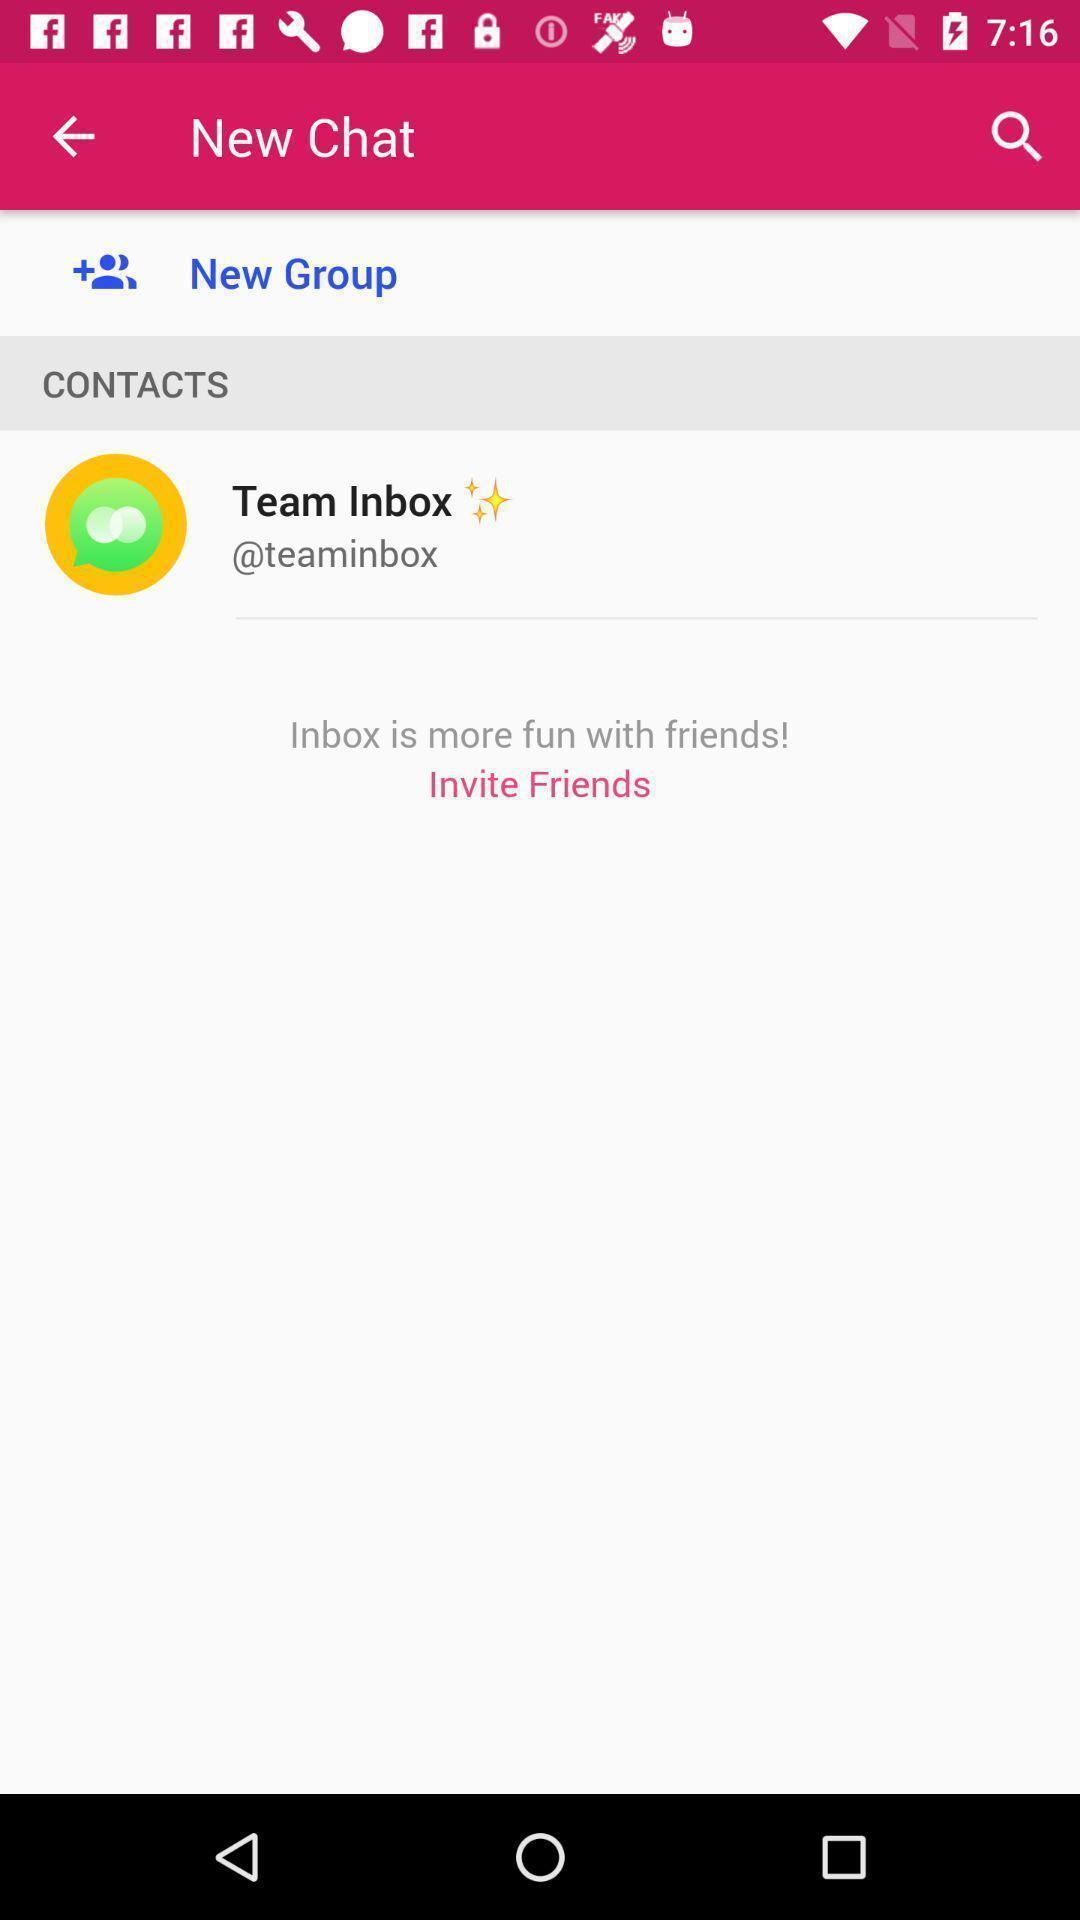What details can you identify in this image? Screen shows new chat contacts. 